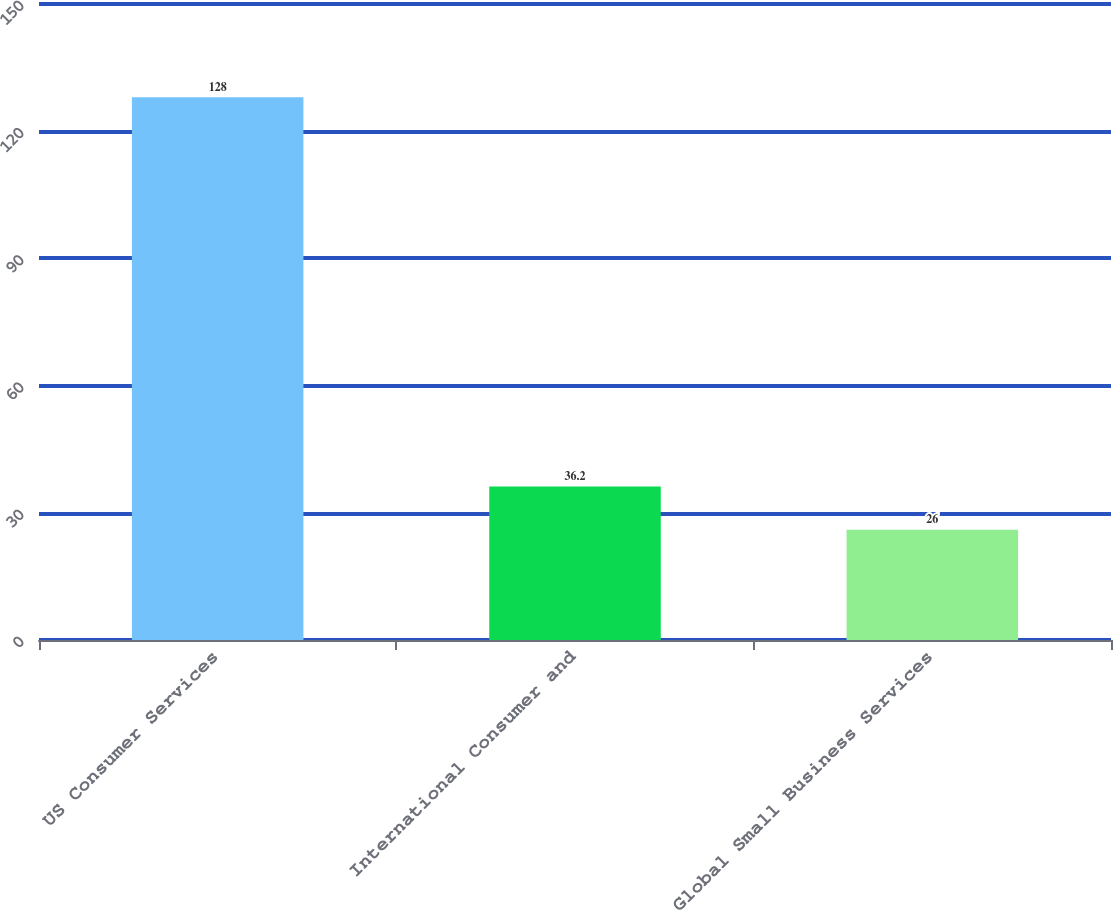Convert chart to OTSL. <chart><loc_0><loc_0><loc_500><loc_500><bar_chart><fcel>US Consumer Services<fcel>International Consumer and<fcel>Global Small Business Services<nl><fcel>128<fcel>36.2<fcel>26<nl></chart> 